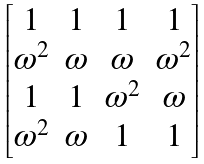Convert formula to latex. <formula><loc_0><loc_0><loc_500><loc_500>\begin{bmatrix} 1 & 1 & 1 & 1 \\ \omega ^ { 2 } & \omega & \omega & \omega ^ { 2 } \\ 1 & 1 & \omega ^ { 2 } & \omega \\ \omega ^ { 2 } & \omega & 1 & 1 \end{bmatrix}</formula> 